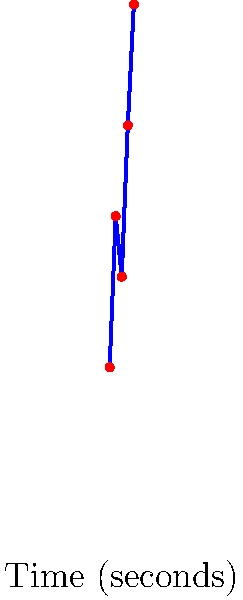As a former student of Santa Rosa Consolidated Schools, you're helping to develop a facial expression recognition system for a school safety project. The graph shows the confidence levels of detecting different emotions in a series of portrait photographs over time. Which emotion was detected with the highest confidence, and what was the approximate confidence percentage? To answer this question, we need to analyze the graph step-by-step:

1. The x-axis represents time in seconds, while the y-axis represents the confidence percentage of emotion detection.

2. Each point on the graph corresponds to a different emotion:
   - At 1 second: Neutral (20% confidence)
   - At 2 seconds: Happy (45% confidence)
   - At 3 seconds: Sad (35% confidence)
   - At 4 seconds: Surprised (60% confidence)
   - At 5 seconds: Angry (80% confidence)

3. To find the emotion detected with the highest confidence, we need to identify the highest point on the graph.

4. The highest point on the graph is at 5 seconds, corresponding to the "Angry" emotion.

5. The y-value for this point is approximately 80%, which represents the confidence percentage for detecting the "Angry" emotion.

Therefore, the emotion detected with the highest confidence was "Angry" with an approximate confidence percentage of 80%.
Answer: Angry, 80% 